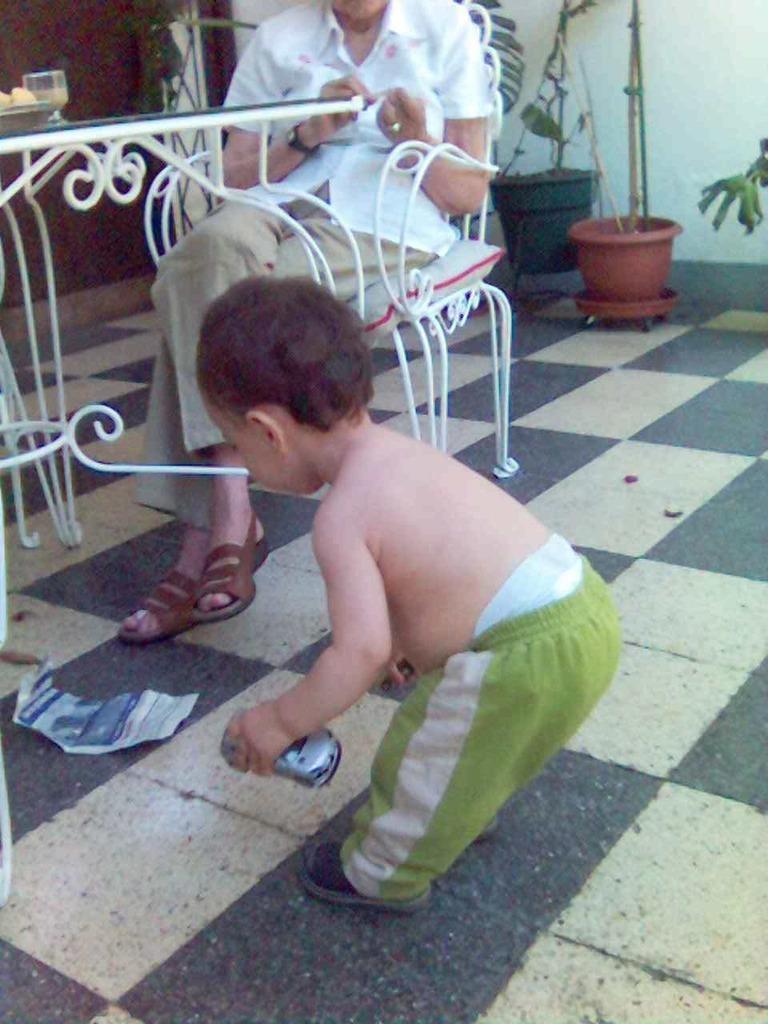Could you give a brief overview of what you see in this image? In this image I can see two persons. In front the person is wearing green color pant and holding some object. Background I can see few plants in green color and the wall is in white color. 